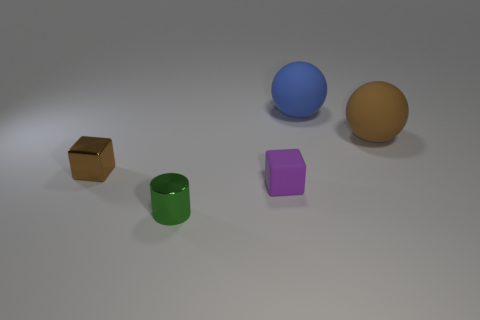What shape is the brown object that is to the left of the cube that is on the right side of the tiny block that is on the left side of the green shiny cylinder?
Provide a short and direct response. Cube. Is there any other thing that has the same material as the large brown ball?
Give a very brief answer. Yes. What is the size of the other shiny thing that is the same shape as the tiny purple thing?
Your answer should be very brief. Small. What color is the tiny object that is behind the green object and right of the small brown metallic object?
Offer a very short reply. Purple. Do the green cylinder and the cube that is on the left side of the purple block have the same material?
Your answer should be compact. Yes. Are there fewer small rubber blocks behind the big blue sphere than blue balls?
Offer a terse response. Yes. How many other objects are there of the same shape as the blue matte object?
Provide a succinct answer. 1. Are there any other things of the same color as the small rubber block?
Offer a terse response. No. Is the color of the shiny cube the same as the big thing behind the brown rubber sphere?
Your response must be concise. No. What number of other things are there of the same size as the brown sphere?
Keep it short and to the point. 1. 